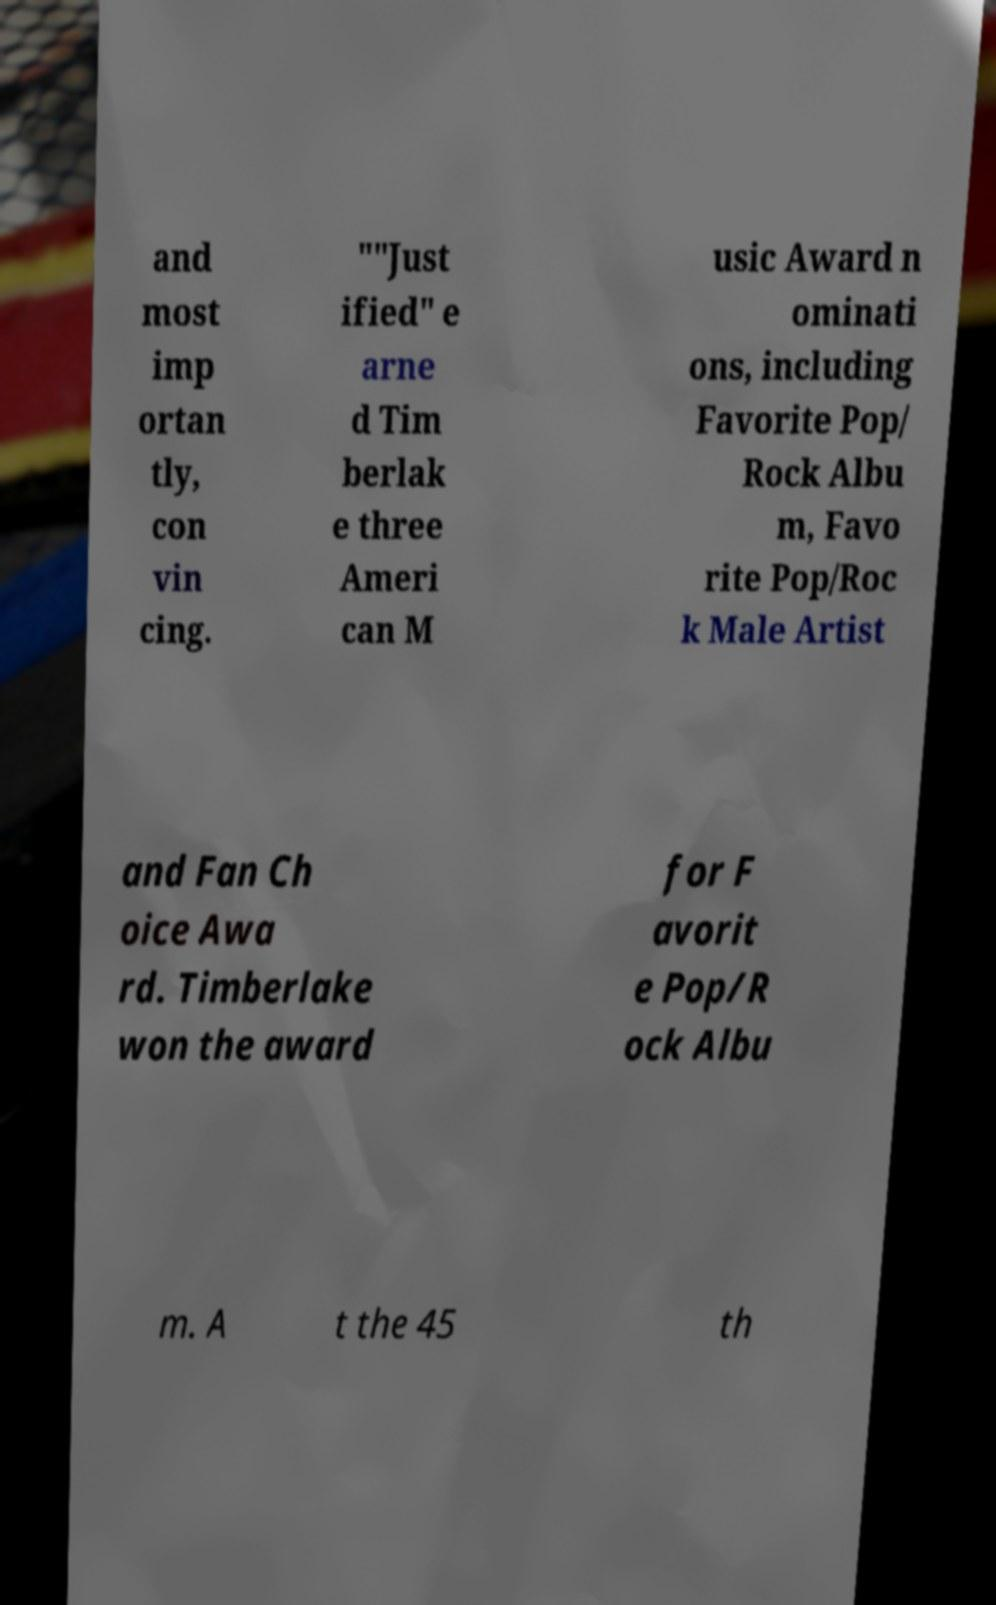Could you extract and type out the text from this image? and most imp ortan tly, con vin cing. ""Just ified" e arne d Tim berlak e three Ameri can M usic Award n ominati ons, including Favorite Pop/ Rock Albu m, Favo rite Pop/Roc k Male Artist and Fan Ch oice Awa rd. Timberlake won the award for F avorit e Pop/R ock Albu m. A t the 45 th 